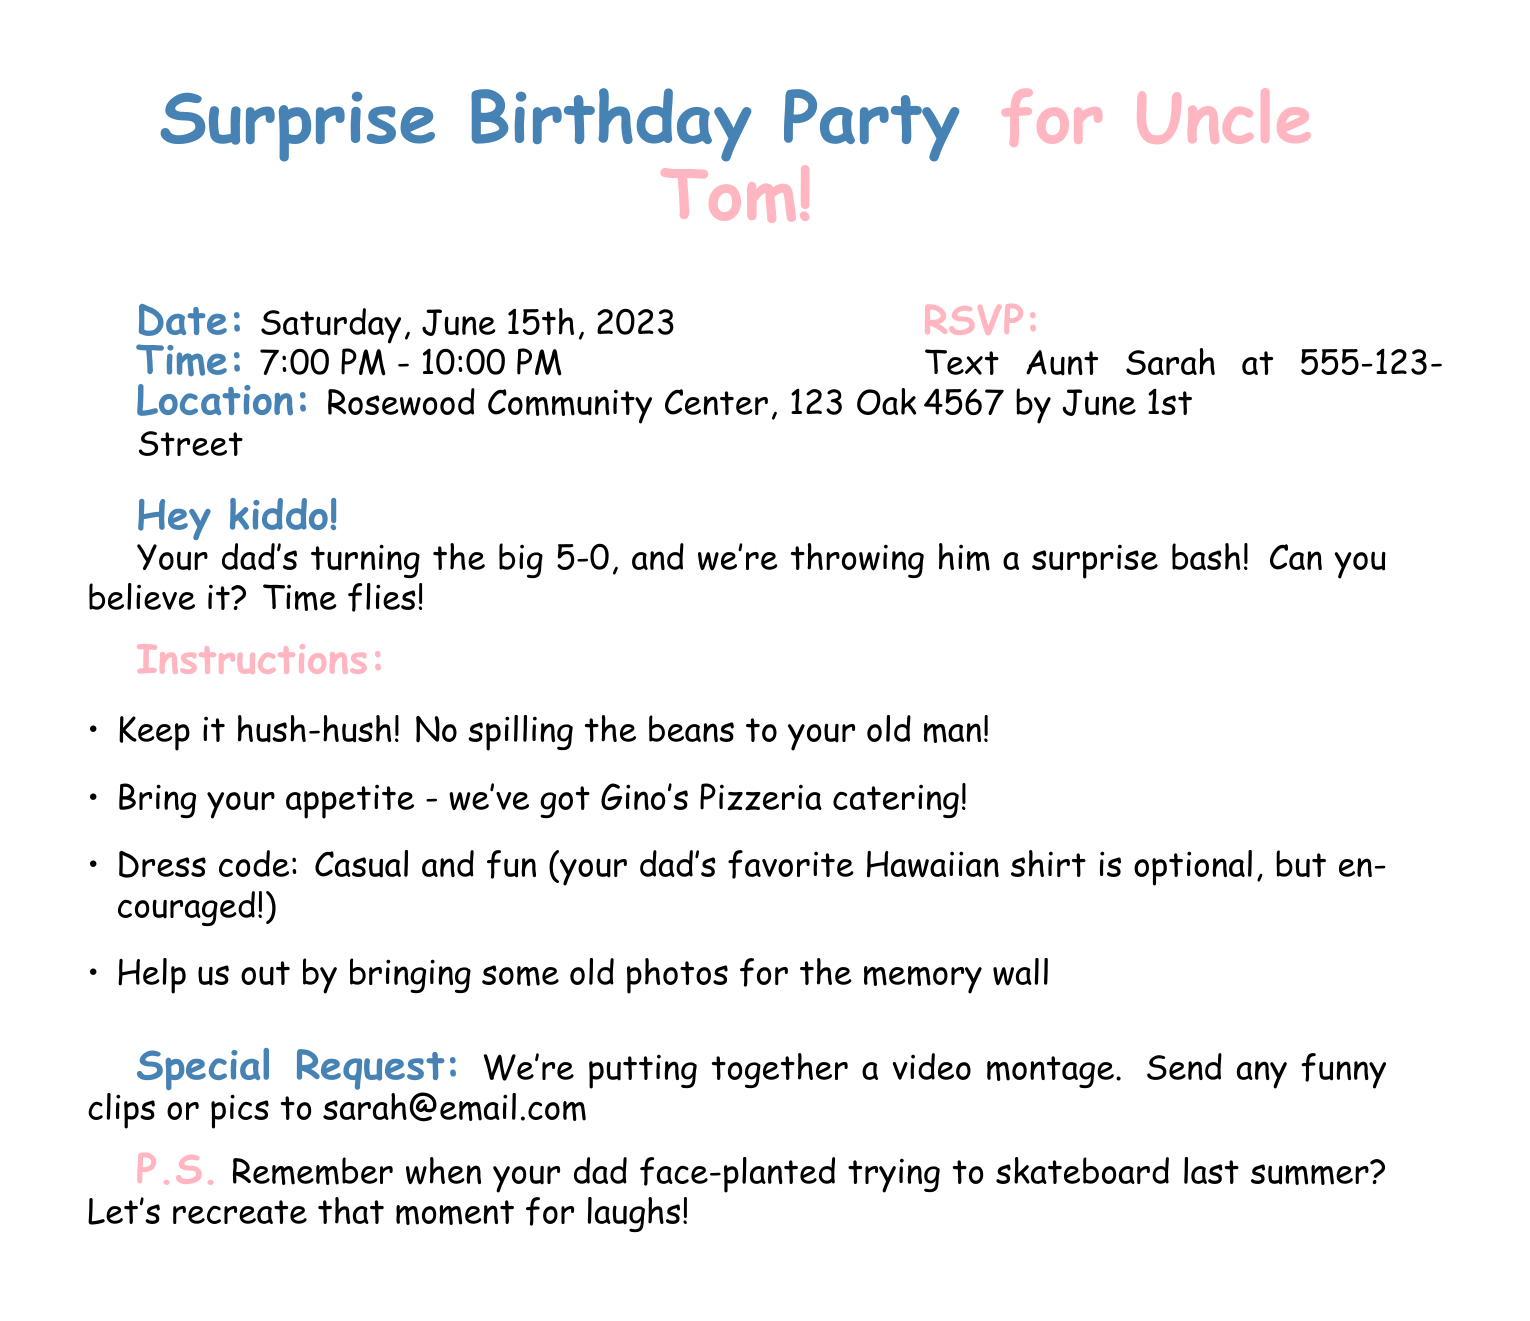What is the date of the surprise party? The date of the surprise party is explicitly mentioned in the document.
Answer: Saturday, June 15th, 2023 What time does the party start? The starting time for the event is stated in the document.
Answer: 7:00 PM Where is the party located? The location of the party is given in the document.
Answer: Rosewood Community Center, 123 Oak Street Who should you text for RSVP? The document specifies who to contact for RSVP.
Answer: Aunt Sarah What is the dress code for the party? The document outlines the expected attire for guests.
Answer: Casual and fun What special request is made in the document? The document contains a special request that is noteworthy for attendees.
Answer: Send any funny clips or pics to sarah@email.com What catering service is being used for the party? The document mentions the catering service that will provide food.
Answer: Gino's Pizzeria What is a suggested contribution for the memory wall? The document requests a specific item to contribute to the memory wall.
Answer: Old photos What is the maximum age that Uncle Tom will turn? The document gives a clue about Uncle Tom's age.
Answer: 50 